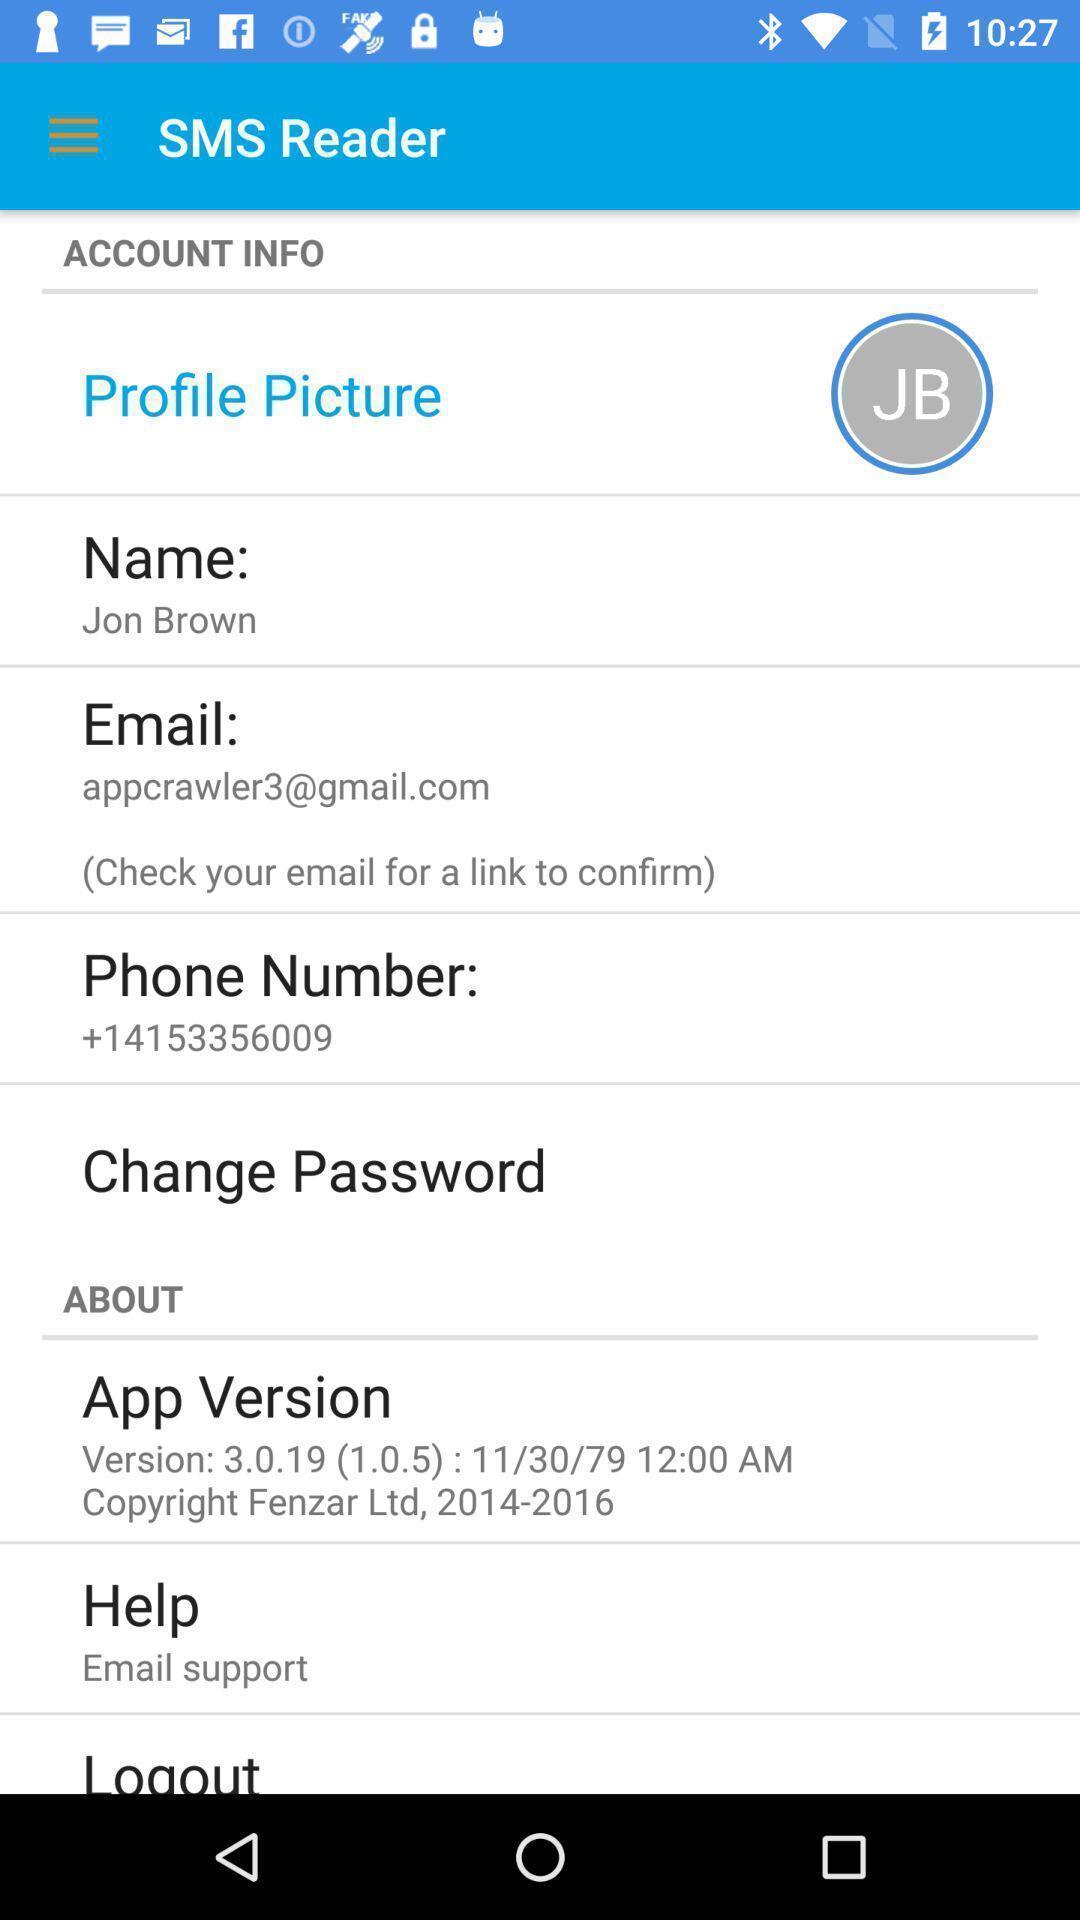Give me a summary of this screen capture. Page showing the profile details. 